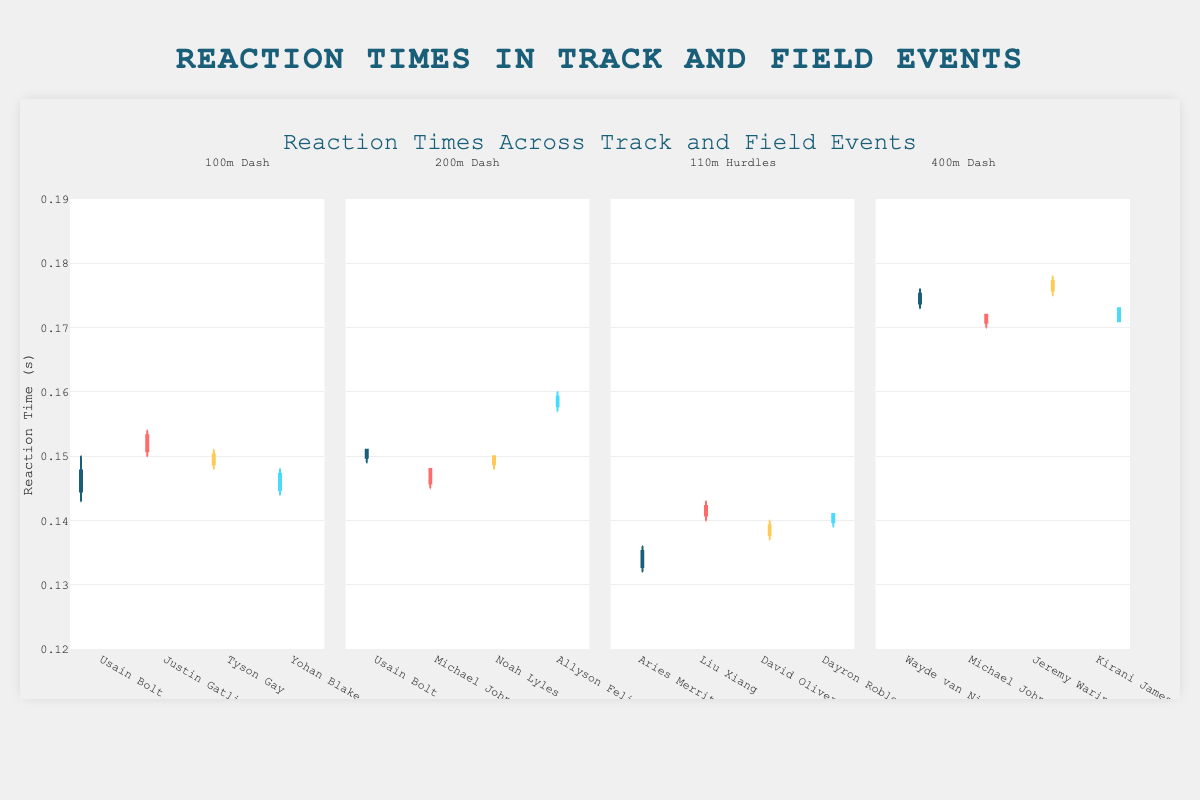What is the title of the figure? The title is displayed at the top of the chart. It helps to understand the overall focus of the figure. The title reads "Reaction Times Across Track and Field Events."
Answer: Reaction Times Across Track and Field Events How many athletes are represented in the 100m Dash category? Each athlete's reaction times are represented by separate box plots. By counting the box plots under the 100m Dash annotation, we find there are 4 athletes.
Answer: 4 Which event has the largest range of reaction times? To determine the range for each event, we compare the distance between the smallest and largest values (whiskers) on each box plot. The 400m Dash category shows the greatest spread in reaction times.
Answer: 400m Dash Who has the lowest median reaction time in the 110m Hurdles event? The median of each box plot is marked by the line within the box. In the 110m Hurdles, Aries Merritt's median line is the lowest among the athletes.
Answer: Aries Merritt Compare the median reaction times of Usain Bolt in 100m Dash and 200m Dash. Which one is faster? The median line inside the box plot represents the median reaction time. Comparing Usain Bolt's plots in both events, the median reaction time in the 100m Dash is lower.
Answer: 100m Dash Which athlete in the 200m Dash event has the highest variation in reaction times? The variation can be assessed by the interquartile range (the length of the box). Allyson Felix has the largest box in the 200m Dash event, indicating the highest variation.
Answer: Allyson Felix Which event shows the smallest range of reaction times overall? The smallest range means the whiskers are close together. In the 110m Hurdles event, the whiskers are closest, indicating the smallest range of reaction times.
Answer: 110m Hurdles Compare the reaction times of Usain Bolt in the 100m Dash and 200m Dash. What is the absolute difference between the highest recorded reaction time in both events? To find this, identify the highest whisker points in both events for Usain Bolt. In 100m Dash, it's 0.150, and in the 200m Dash, it's 0.151. The absolute difference is 0.001 seconds.
Answer: 0.001 seconds How do the reaction times of Michael Johnson in the 200m Dash and 400m Dash compare? Compare the box plots for both events. Michael Johnson's median reaction time in the 200m Dash is higher than in the 400m dash, showing he is slightly faster in the 400m event.
Answer: Faster in 400m Which athlete in the 400m Dash event has the most consistent reaction times? The most consistent times would have the smallest interquartile range (small box). In the 400m Dash event, Michael Johnson's box is the smallest, showing consistent reaction times.
Answer: Michael Johnson Considering all athletes, who has the lowest recorded reaction time and in which event? The lowest recorded reaction time is indicated by the bottom whisker. Aries Merritt in the 110m Hurdles event has the lowest recorded reaction time of 0.132 seconds.
Answer: Aries Merritt in 110m Hurdles 